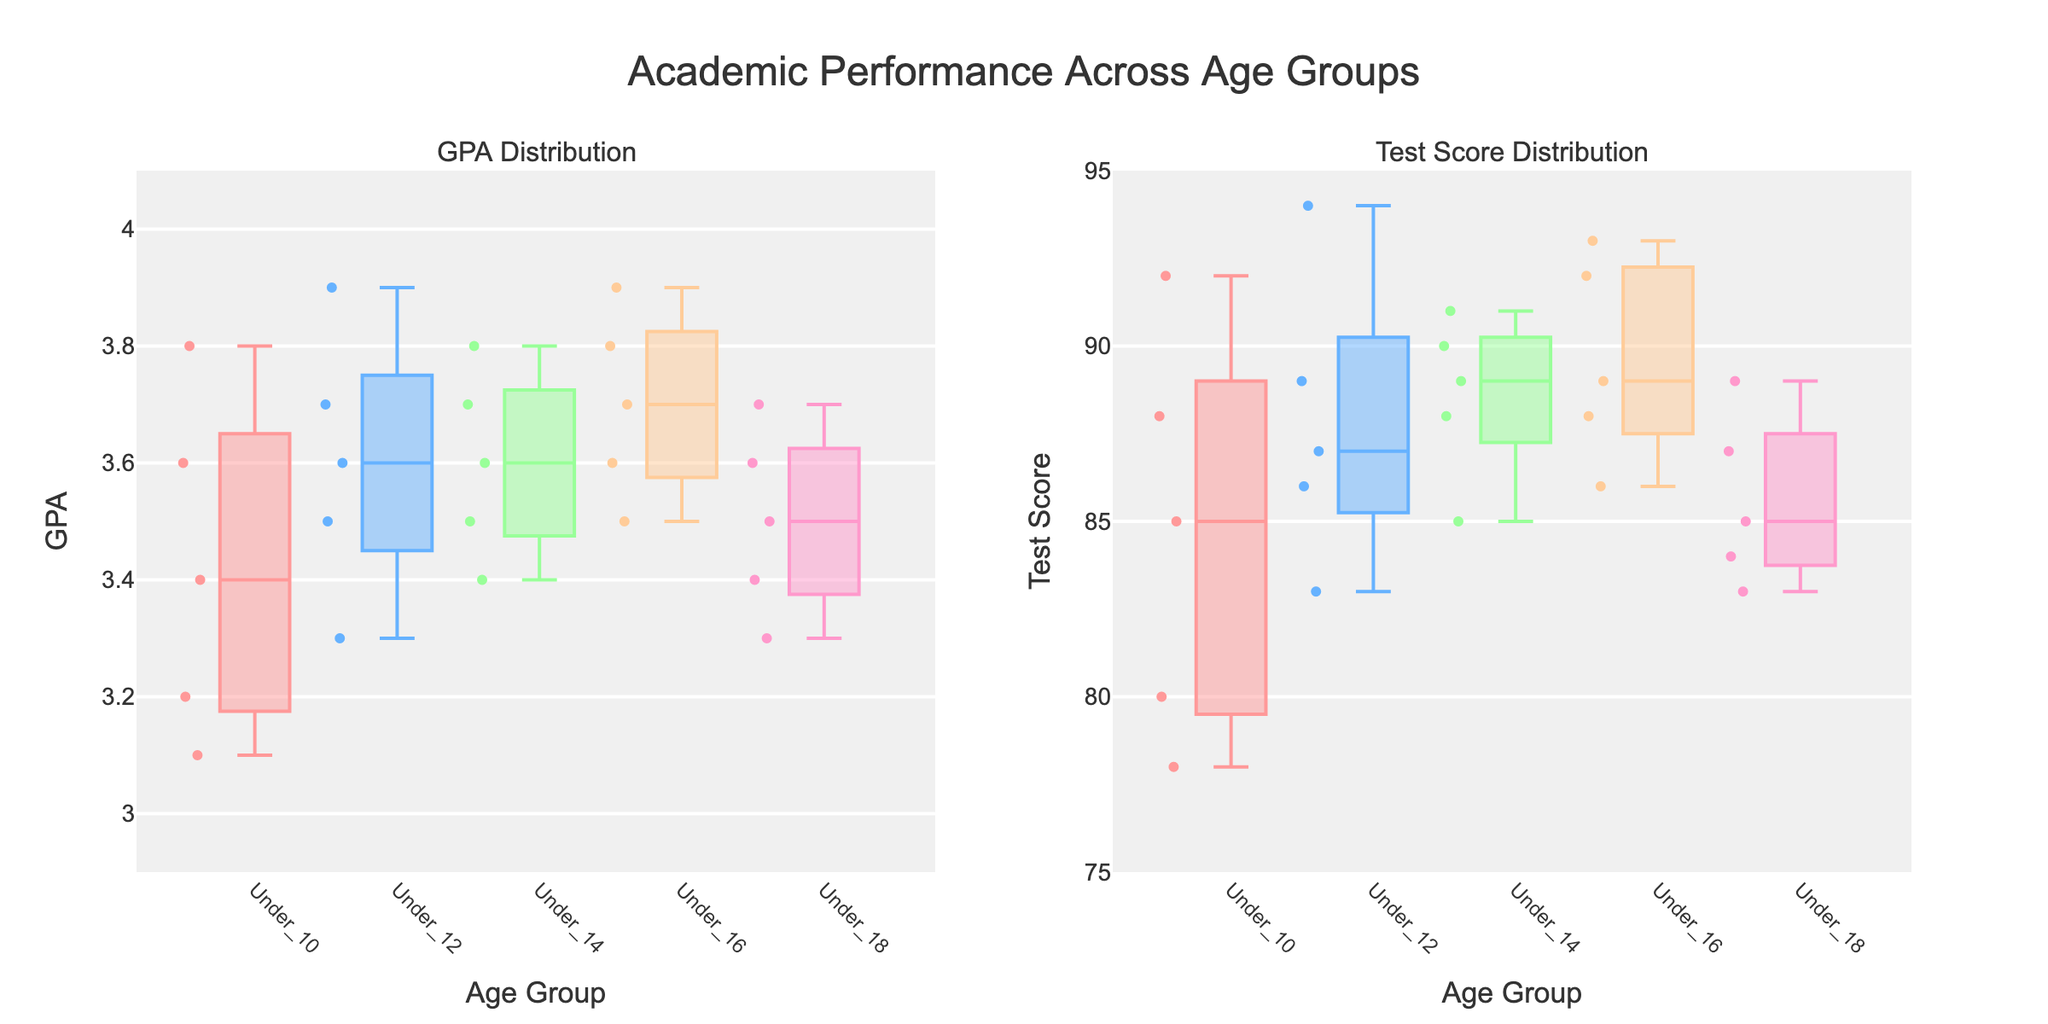what's the title of the figure? The title of the figure can be found at the top and often summarizes the main focus of the plot. In this case, it reads "Academic Performance Across Age Groups."
Answer: Academic Performance Across Age Groups what are the age groups compared in the figure? The age groups can be identified by looking at the labels on the x-axes for both subplots. They include Under_10, Under_12, Under_14, Under_16, and Under_18.
Answer: Under_10, Under_12, Under_14, Under_16, Under_18 which age group has the highest median GPA? By examining the median lines in the box plots for GPA (left subplot), the age group with the highest median GPA can be identified. The Under_16 group has the highest median GPA.
Answer: Under_16 Which age group shows the largest range in test scores? The range of the test scores can be observed by identifying the age group with the longest box in the Test Score subplot (right plot). The Under_12 group appears to show the largest range.
Answer: Under_12 what's the median test score for the Under_12 age group? Look at the box plot for the Under_12 age group in the Test Score subplot. The median is indicated by the line inside the box. The median test score for the Under_12 group is 87.
Answer: 87 how many GPA data points are there in the Under_10 age group? Count the number of individual points plotted inside and outside the box plot for the Under_10 group in the GPA subplot. There are 5 points.
Answer: 5 which age group has the smallest interquartile range (IQR) for GPA? The IQR is the length of the box in the box plot. The smallest box in the GPA subplot corresponds to the smallest IQR, which is the Under_12 group.
Answer: Under_12 compare the median GPAs of Under_14 and Under_18. which is higher? Look at the median lines in the GPA subplot for both Under_14 and Under_18. The Under_14 group has a higher median GPA compared to Under_18.
Answer: Under_14 what's the main color used for the Under_16 age group in both plots? Colors used for each subplot's individual age group can help identify them. The Under_16 age group is represented by a blue color in both subplots.
Answer: blue what's the overlap between the highest GPA in the Under_10 age group and the lowest GPA in the Under_16 age group? Identify the highest outlier for the Under_10 group and compare it with the lowest value in the Under_16 box plot. The highest GPA in Under_10 is 3.8, and the lowest in Under_16 is 3.5. There is no overlap.
Answer: No overlap 